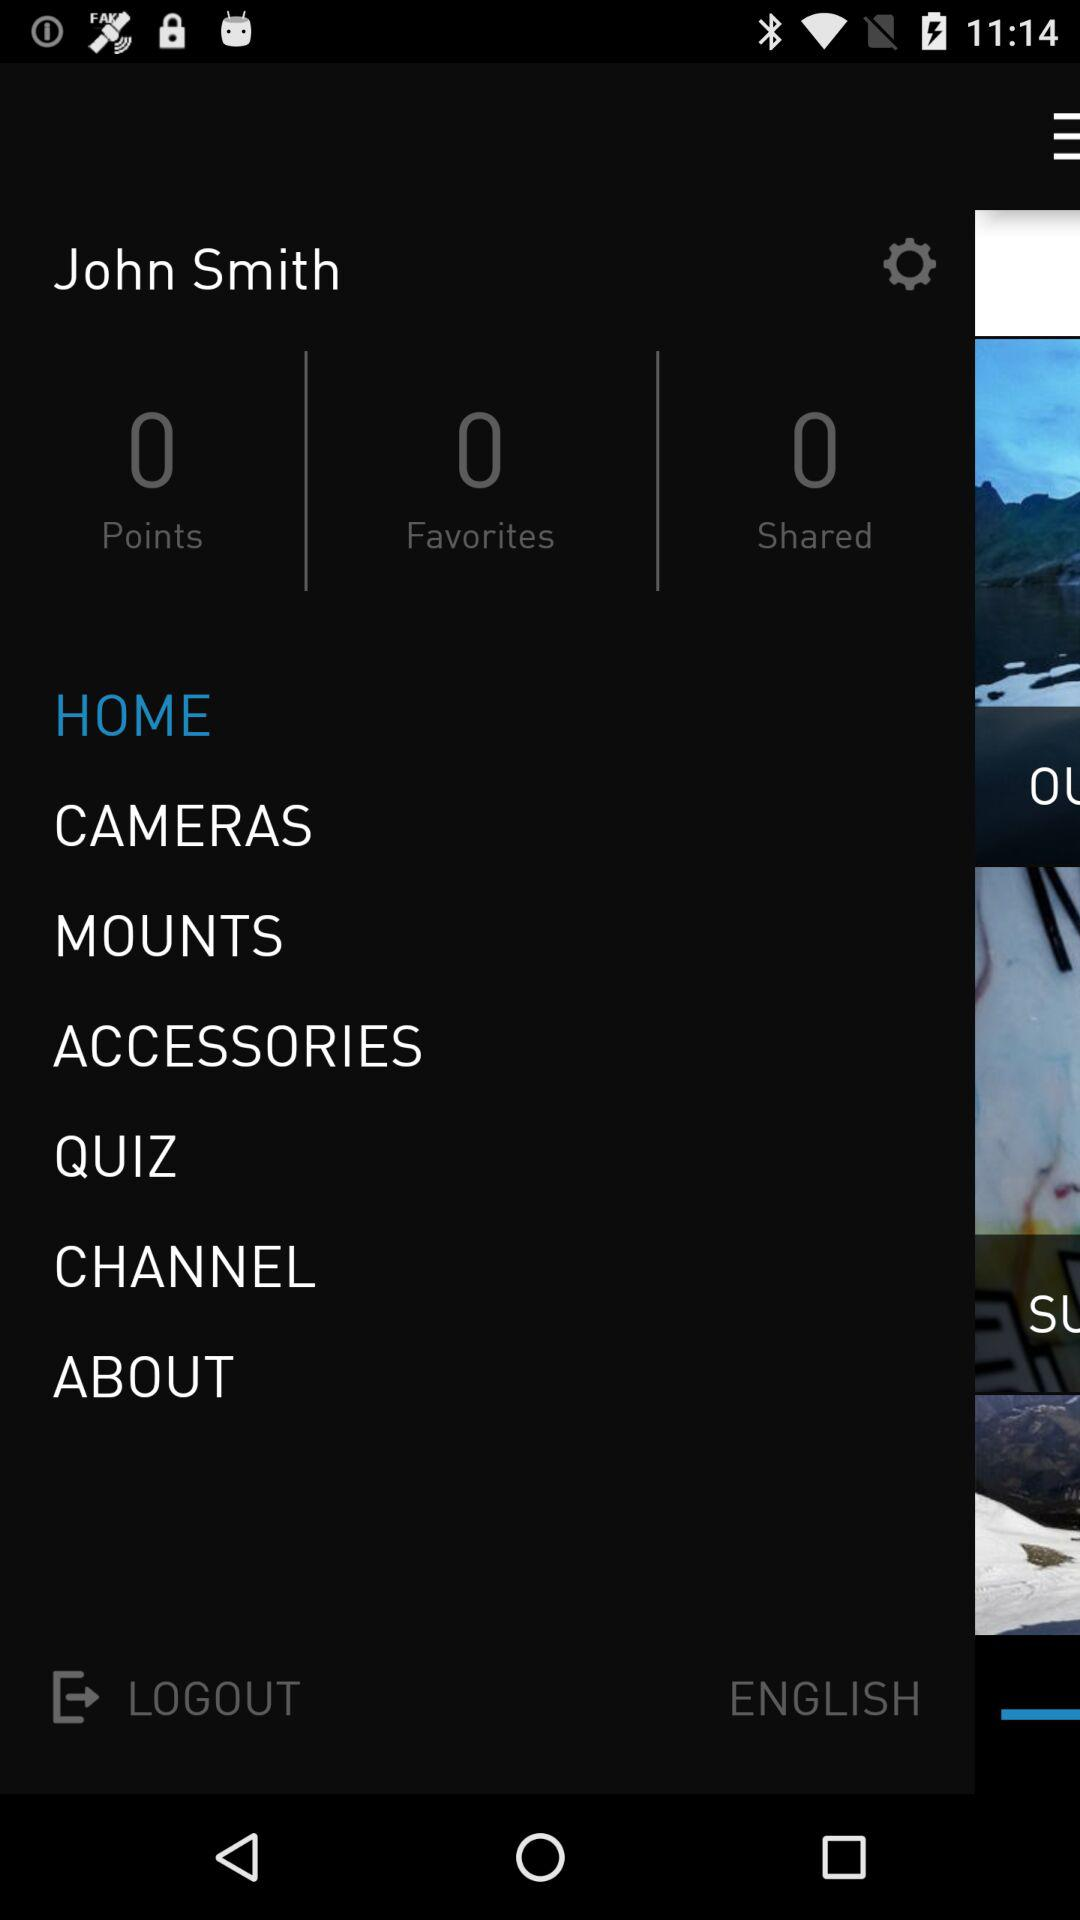How many favorites points earned?
When the provided information is insufficient, respond with <no answer>. <no answer> 